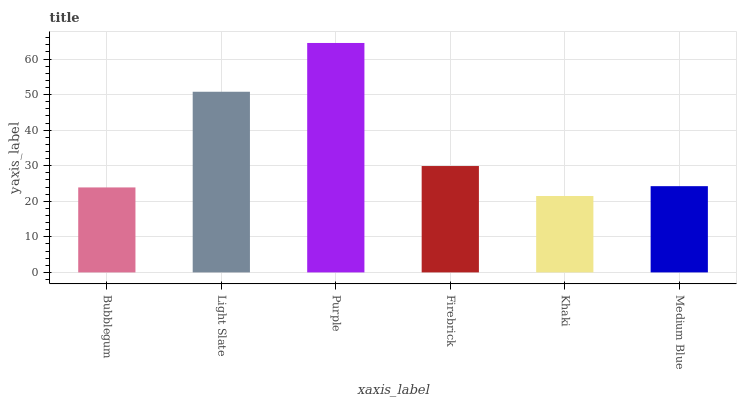Is Khaki the minimum?
Answer yes or no. Yes. Is Purple the maximum?
Answer yes or no. Yes. Is Light Slate the minimum?
Answer yes or no. No. Is Light Slate the maximum?
Answer yes or no. No. Is Light Slate greater than Bubblegum?
Answer yes or no. Yes. Is Bubblegum less than Light Slate?
Answer yes or no. Yes. Is Bubblegum greater than Light Slate?
Answer yes or no. No. Is Light Slate less than Bubblegum?
Answer yes or no. No. Is Firebrick the high median?
Answer yes or no. Yes. Is Medium Blue the low median?
Answer yes or no. Yes. Is Light Slate the high median?
Answer yes or no. No. Is Purple the low median?
Answer yes or no. No. 